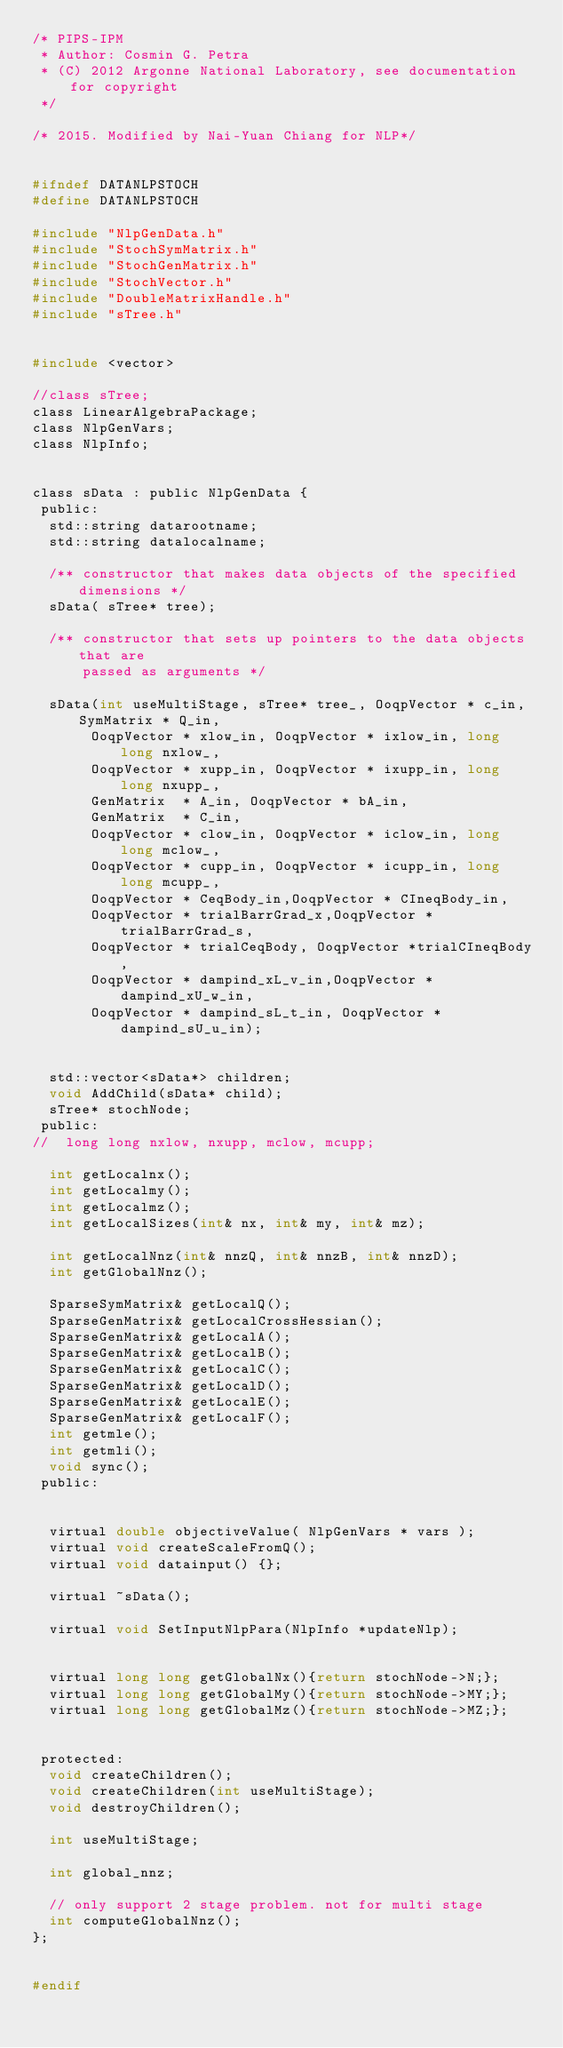<code> <loc_0><loc_0><loc_500><loc_500><_C_>/* PIPS-IPM                                                             
 * Author: Cosmin G. Petra
 * (C) 2012 Argonne National Laboratory, see documentation for copyright
 */
 
/* 2015. Modified by Nai-Yuan Chiang for NLP*/


#ifndef DATANLPSTOCH
#define DATANLPSTOCH

#include "NlpGenData.h"
#include "StochSymMatrix.h"
#include "StochGenMatrix.h"
#include "StochVector.h"
#include "DoubleMatrixHandle.h"
#include "sTree.h"


#include <vector>

//class sTree;
class LinearAlgebraPackage;
class NlpGenVars;
class NlpInfo;


class sData : public NlpGenData {
 public:
  std::string datarootname;
  std::string datalocalname;
  
  /** constructor that makes data objects of the specified dimensions */
  sData( sTree* tree);

  /** constructor that sets up pointers to the data objects that are
      passed as arguments */

  sData(int useMultiStage, sTree* tree_, OoqpVector * c_in, SymMatrix * Q_in,
	     OoqpVector * xlow_in, OoqpVector * ixlow_in, long long nxlow_,
	     OoqpVector * xupp_in, OoqpVector * ixupp_in, long long nxupp_,
	     GenMatrix  * A_in, OoqpVector * bA_in,
	     GenMatrix  * C_in,
	     OoqpVector * clow_in, OoqpVector * iclow_in, long long mclow_,
	     OoqpVector * cupp_in, OoqpVector * icupp_in, long long mcupp_,
	     OoqpVector * CeqBody_in,OoqpVector * CIneqBody_in,
	     OoqpVector * trialBarrGrad_x,OoqpVector * trialBarrGrad_s,
	     OoqpVector * trialCeqBody, OoqpVector *trialCIneqBody,
	     OoqpVector * dampind_xL_v_in,OoqpVector * dampind_xU_w_in,
	     OoqpVector * dampind_sL_t_in, OoqpVector *dampind_sU_u_in);

  
  std::vector<sData*> children;
  void AddChild(sData* child);
  sTree* stochNode;
 public:
//  long long nxlow, nxupp, mclow, mcupp;

  int getLocalnx();
  int getLocalmy();
  int getLocalmz();
  int getLocalSizes(int& nx, int& my, int& mz);

  int getLocalNnz(int& nnzQ, int& nnzB, int& nnzD);
  int getGlobalNnz();  

  SparseSymMatrix& getLocalQ();
  SparseGenMatrix& getLocalCrossHessian();
  SparseGenMatrix& getLocalA();
  SparseGenMatrix& getLocalB();
  SparseGenMatrix& getLocalC();
  SparseGenMatrix& getLocalD();
  SparseGenMatrix& getLocalE();
  SparseGenMatrix& getLocalF();
  int getmle();
  int getmli();  
  void sync();
 public:


  virtual double objectiveValue( NlpGenVars * vars );
  virtual void createScaleFromQ();
  virtual void datainput() {};

  virtual ~sData();

  virtual void SetInputNlpPara(NlpInfo *updateNlp);


  virtual long long getGlobalNx(){return stochNode->N;};
  virtual long long getGlobalMy(){return stochNode->MY;};
  virtual long long getGlobalMz(){return stochNode->MZ;};


 protected:
  void createChildren();
  void createChildren(int useMultiStage);
  void destroyChildren();

  int useMultiStage;

  int global_nnz;

  // only support 2 stage problem. not for multi stage 
  int computeGlobalNnz();  
};


#endif
</code> 